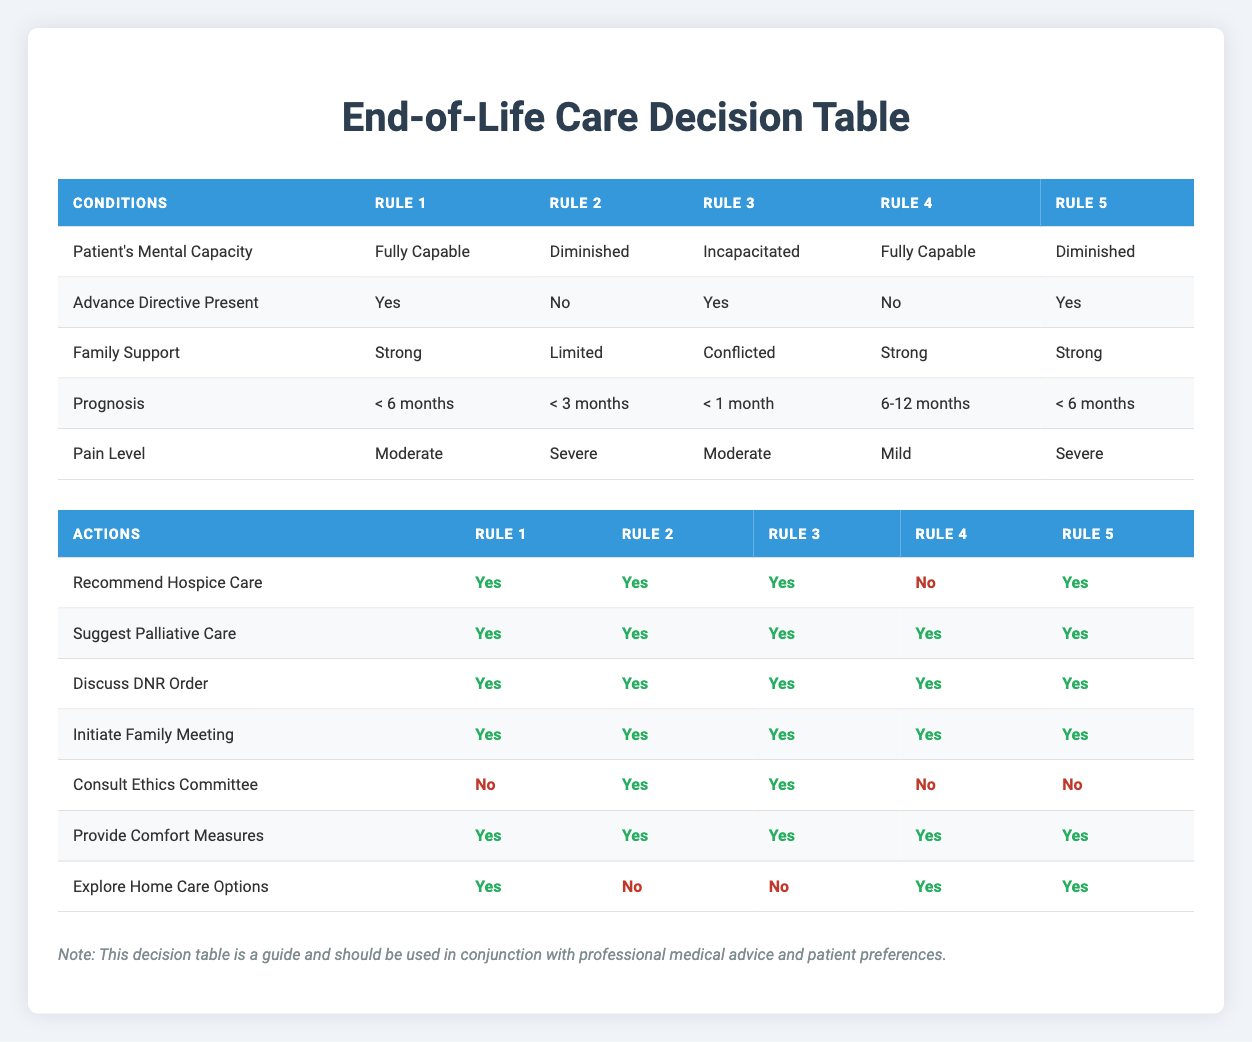What actions are taken when the patient is fully capable with a prognosis of less than 6 months? From Rule 1 in the table, for a fully capable patient with a prognosis of less than 6 months, the actions taken are: Recommend Hospice Care (Yes), Suggest Palliative Care (Yes), Discuss DNR Order (Yes), Initiate Family Meeting (Yes), Consult Ethics Committee (No), Provide Comfort Measures (Yes), and Explore Home Care Options (Yes).
Answer: Recommend Hospice Care: Yes, Suggest Palliative Care: Yes, Discuss DNR Order: Yes, Initiate Family Meeting: Yes, Consult Ethics Committee: No, Provide Comfort Measures: Yes, Explore Home Care Options: Yes Is there any situation in which home care options are not explored? Yes, based on Rule 2 and Rule 3, where either the patient's mental capacity is diminished or incapacitated with severe pain and limited family support.
Answer: Yes How many rules recommend hospice care? There are four rules recommending hospice care, which can be seen in Rules 1, 2, 3, and 5.
Answer: Four What is the maximum pain level among all rules listed for patients categorized as incapacitated? In Rule 3, the patient's pain level is Moderate, which is the only instance for incapacitated patients in the table.
Answer: Moderate Which conditions lead to consulting the Ethics Committee? According to Rule 2 and Rule 3, consulting the Ethics Committee is necessary when the patient's mental capacity is diminished or incapacitated with severe pain levels.
Answer: Diminished and Incapacitated What actions can be taken if the patient is fully capable, has no advance directive, has strong family support, and a prognosis of 6-12 months? From Rule 4, the actions taken are: Recommend Hospice Care (No), Suggest Palliative Care (Yes), Discuss DNR Order (Yes), Initiate Family Meeting (Yes), Consult Ethics Committee (No), Provide Comfort Measures (Yes), and Explore Home Care Options (Yes).
Answer: Recommend Hospice Care: No, Suggest Palliative Care: Yes, Discuss DNR Order: Yes, Initiate Family Meeting: Yes, Consult Ethics Committee: No, Provide Comfort Measures: Yes, Explore Home Care Options: Yes How does the prognosis of less than 3 months affect family support for a diminished capacity patient? The table indicates under Rule 2 that for a patient with diminished mental capacity and a prognosis of less than 3 months, family support is limited.
Answer: Limited In cases where advance directive is present for a patient with diminished capacity, how does it change the overall care actions? Rule 5 shows that even when a patient has diminished capacity but an advance directive is present, the recommended actions such as hospice care, palliative care, DNR discussions, and family meetings remain the same. However, consulting the Ethics Committee is not necessary in this case.
Answer: No change in recommended actions, but no need to consult Ethics Committee 